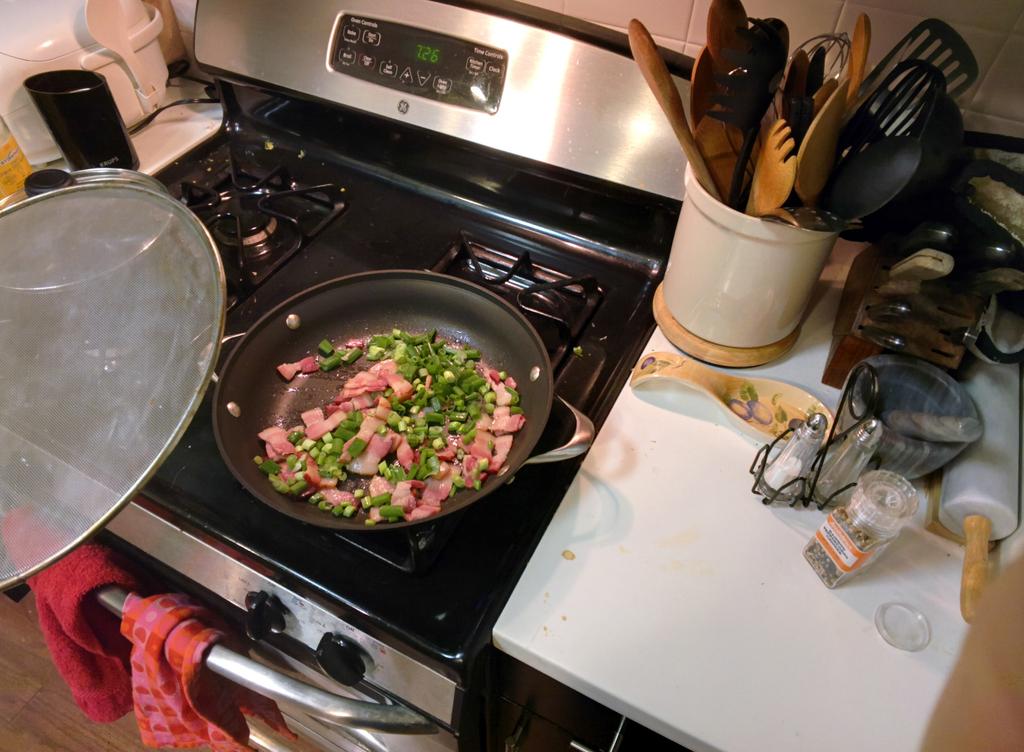What time is it, stated on the stove?
Your response must be concise. 7:26. 